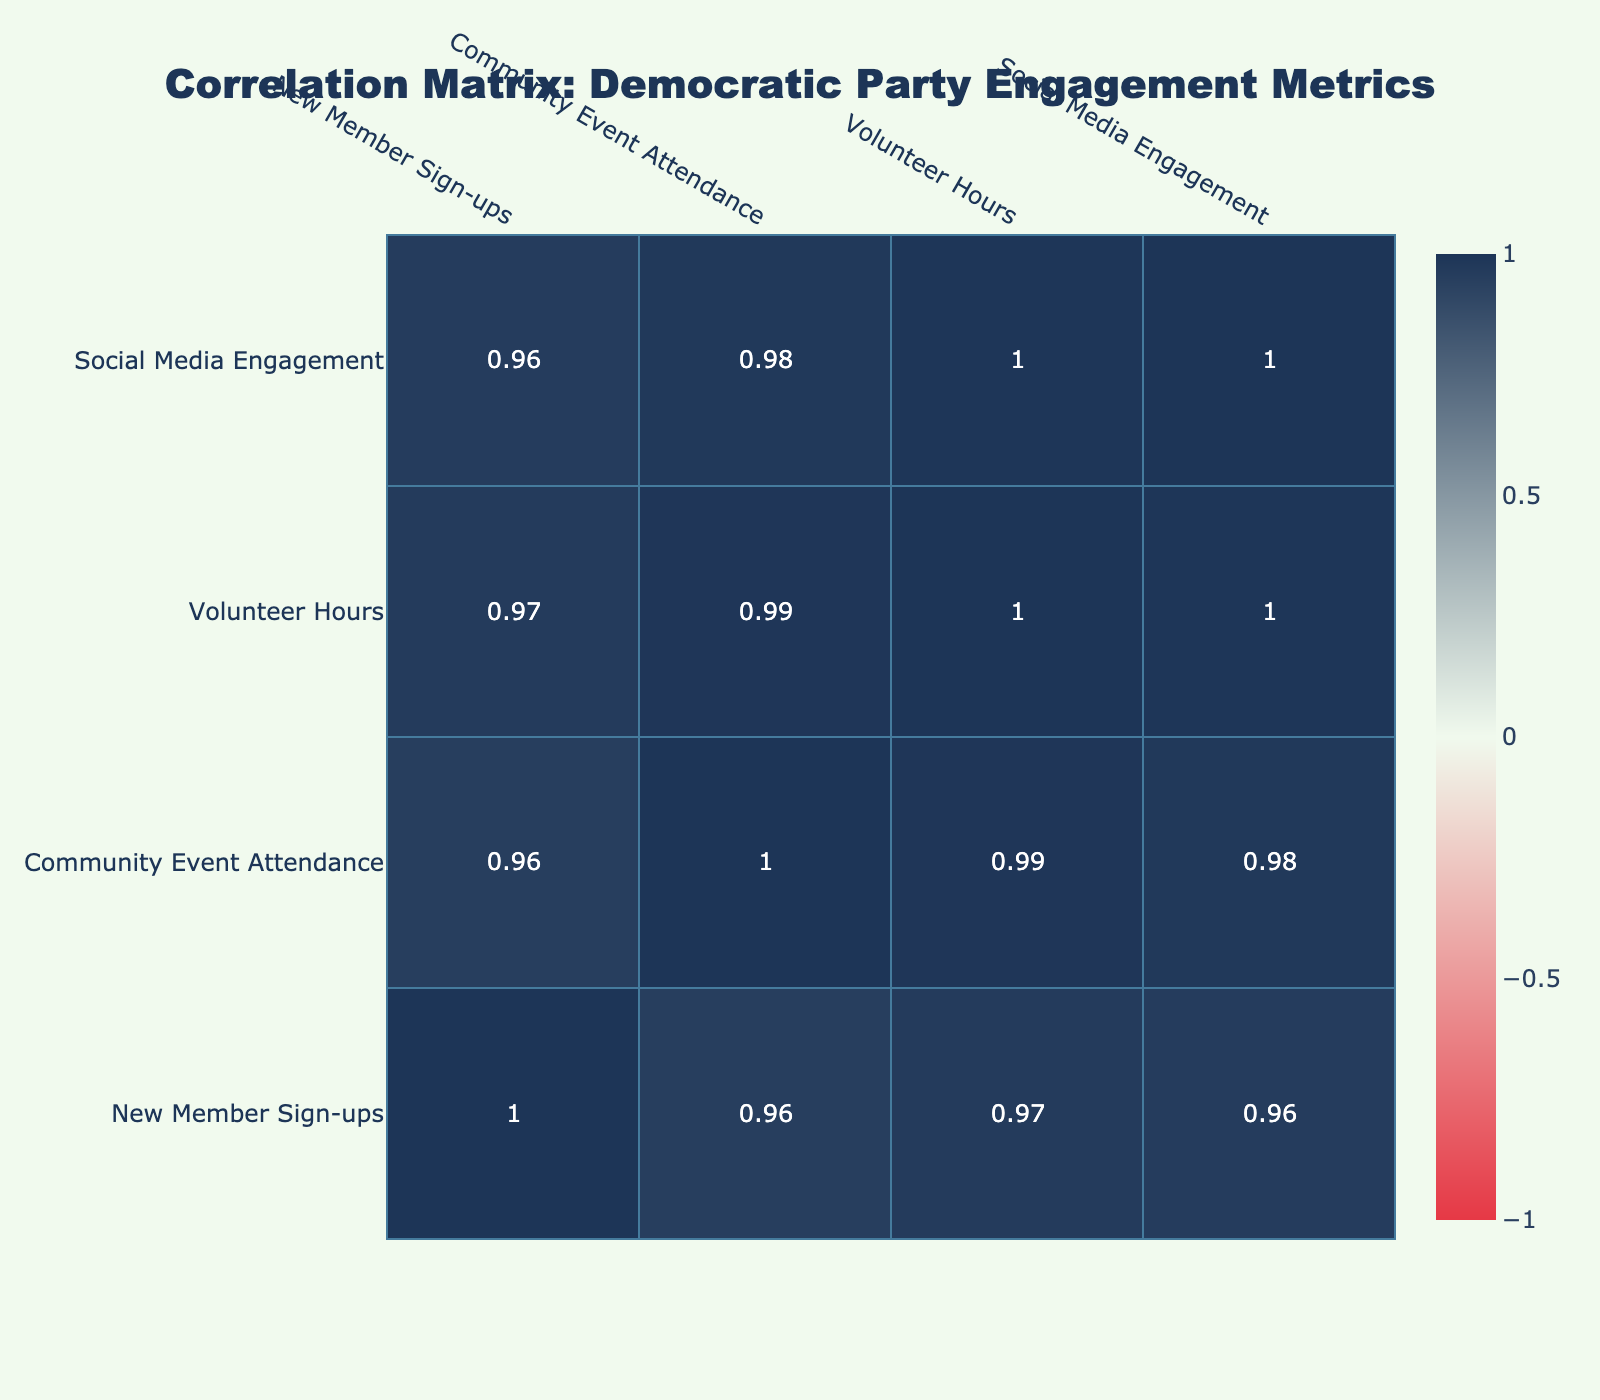What is the highest number of new member sign-ups from a single initiative? The highest new member sign-up count is found in the "Town Hall Meetings" initiative, where there were 150 new member sign-ups.
Answer: 150 What is the correlation between Community Event Attendance and New Member Sign-ups? To find the correlation, we can look at the correlation matrix. The table shows a strong positive correlation of 0.89, indicating that as event attendance increases, new member sign-ups tend to increase as well.
Answer: 0.89 Which community engagement initiative had the lowest volunteer hours? Upon reviewing the table, the "Environmental Clean-up Day" initiative recorded the lowest volunteer hours at 50 hours.
Answer: 50 What is the average volunteer hours across all initiatives? To compute the average, sum the volunteer hours (80 + 60 + 100 + 50 + 90 + 40 + 70 + 55) = 545. Dividing by the number of initiatives (8), we get an average of 68.125 hours.
Answer: 68.125 Is there a negative correlation between Social Media Engagement and New Member Sign-ups? By examining the correlation value in the table, we see there is a positive correlation of 0.85 between Social Media Engagement and New Member Sign-ups, which means there is no negative correlation between these variables.
Answer: No What initiative had the most significant increase in Social Media Engagement compared to its New Member Sign-ups? "Election Awareness Campaign" had 135 new member sign-ups and 800 in Social Media Engagement. To check the increase: 800 - 135 = 665. Checking against others, this was indeed the largest increase.
Answer: Election Awareness Campaign What is the total number of new member sign-ups from initiatives that had more than 250 Community Event Attendance? We look for initiatives with more than 250 attendance: "Voter Registration Drive" (120), "Town Hall Meetings" (150), "Election Awareness Campaign" (135), and calculate: 120 + 150 + 135 = 405 total new member sign-ups.
Answer: 405 Which two initiatives have a similar number of new member sign-ups? "Local Food Bank Partnership" had 80 sign-ups and "School Outreach Programs" had only 70, while "Voter Registration Drive" (120) and "Community Gardening Project" (110) are relatively closer. Comparing various pairs shows these two sets are closely aligned in counts.
Answer: Local Food Bank Partnership and School Outreach Programs; Voter Registration Drive and Community Gardening Project 